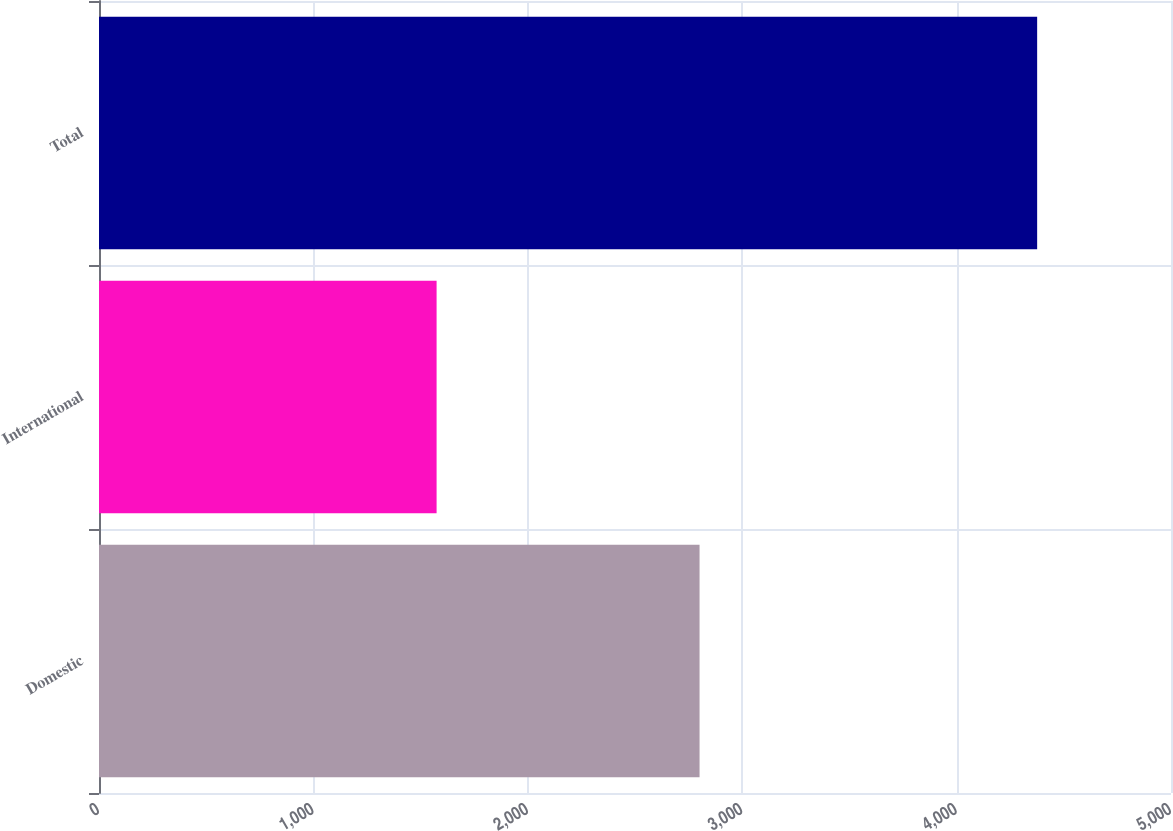Convert chart. <chart><loc_0><loc_0><loc_500><loc_500><bar_chart><fcel>Domestic<fcel>International<fcel>Total<nl><fcel>2801.1<fcel>1574.6<fcel>4375.7<nl></chart> 